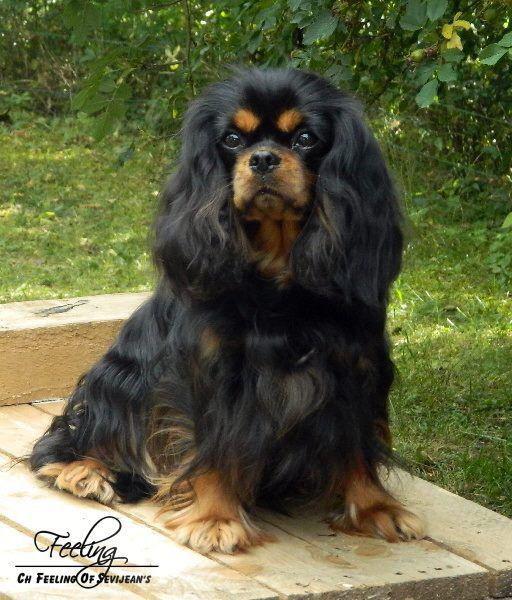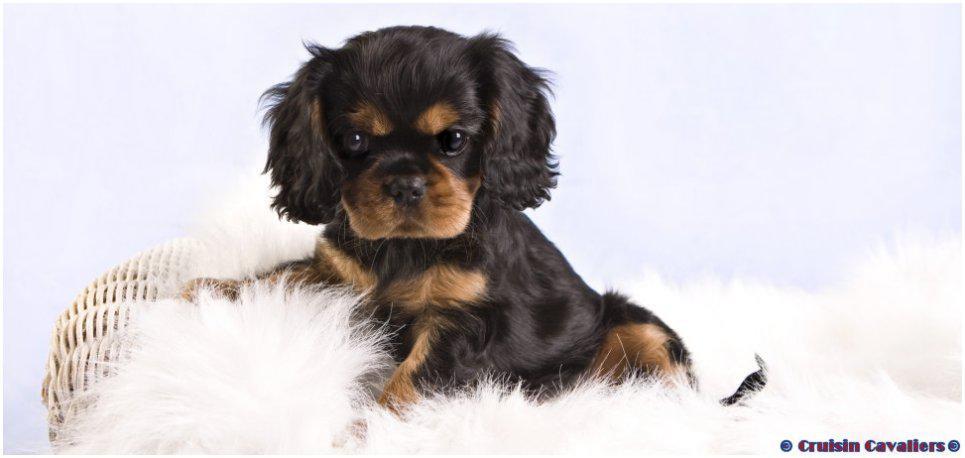The first image is the image on the left, the second image is the image on the right. For the images displayed, is the sentence "The dog on the left is sitting on a wood surface." factually correct? Answer yes or no. Yes. The first image is the image on the left, the second image is the image on the right. Considering the images on both sides, is "An image features two similarly colored dogs posed next to each other." valid? Answer yes or no. No. 